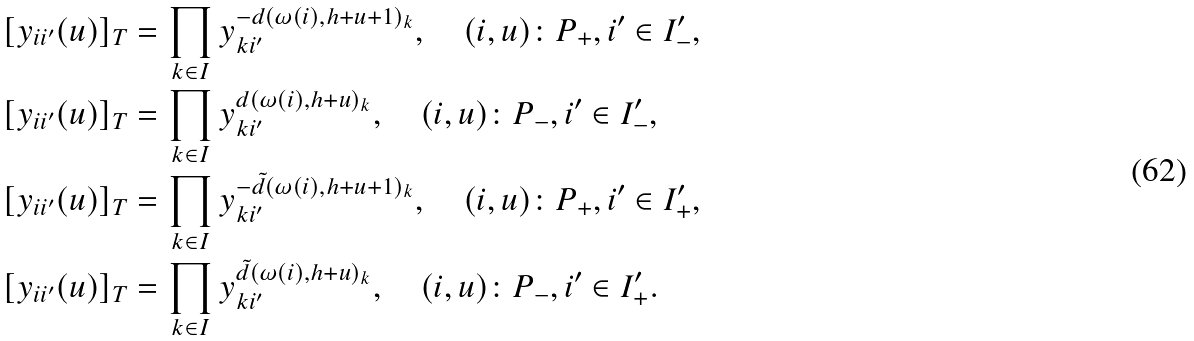<formula> <loc_0><loc_0><loc_500><loc_500>[ y _ { i i ^ { \prime } } ( u ) ] _ { T } & = \prod _ { k \in I } y _ { k i ^ { \prime } } ^ { - d ( \omega ( i ) , h + u + 1 ) _ { k } } , \quad ( i , u ) \colon P _ { + } , i ^ { \prime } \in I ^ { \prime } _ { - } , \\ [ y _ { i i ^ { \prime } } ( u ) ] _ { T } & = \prod _ { k \in I } y _ { k i ^ { \prime } } ^ { d ( \omega ( i ) , h + u ) _ { k } } , \quad ( i , u ) \colon P _ { - } , i ^ { \prime } \in I ^ { \prime } _ { - } , \\ [ y _ { i i ^ { \prime } } ( u ) ] _ { T } & = \prod _ { k \in I } y _ { k i ^ { \prime } } ^ { - \tilde { d } ( \omega ( i ) , h + u + 1 ) _ { k } } , \quad ( i , u ) \colon P _ { + } , i ^ { \prime } \in I ^ { \prime } _ { + } , \\ [ y _ { i i ^ { \prime } } ( u ) ] _ { T } & = \prod _ { k \in I } y _ { k i ^ { \prime } } ^ { \tilde { d } ( \omega ( i ) , h + u ) _ { k } } , \quad ( i , u ) \colon P _ { - } , i ^ { \prime } \in I ^ { \prime } _ { + } .</formula> 